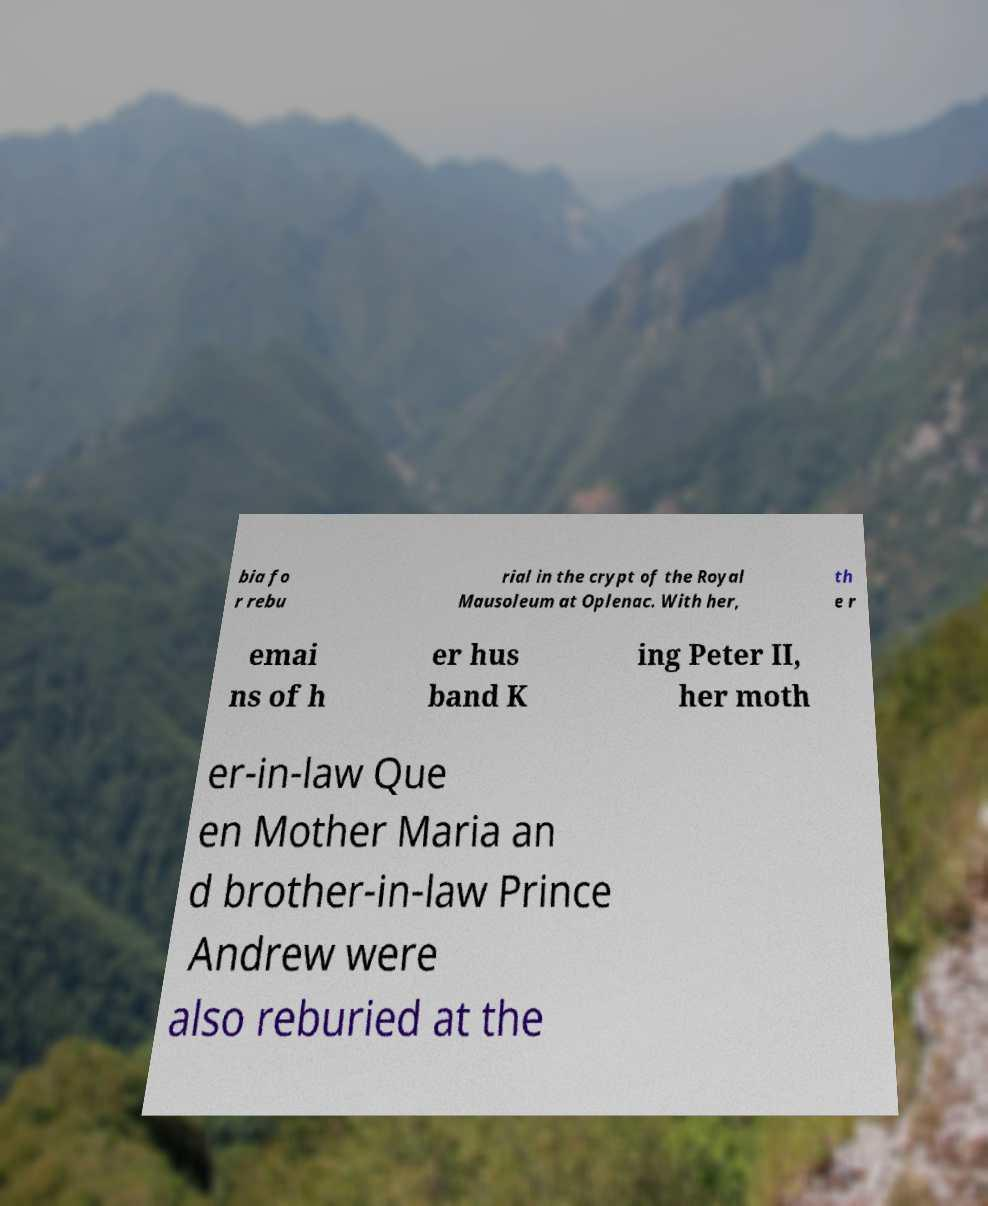Please identify and transcribe the text found in this image. bia fo r rebu rial in the crypt of the Royal Mausoleum at Oplenac. With her, th e r emai ns of h er hus band K ing Peter II, her moth er-in-law Que en Mother Maria an d brother-in-law Prince Andrew were also reburied at the 